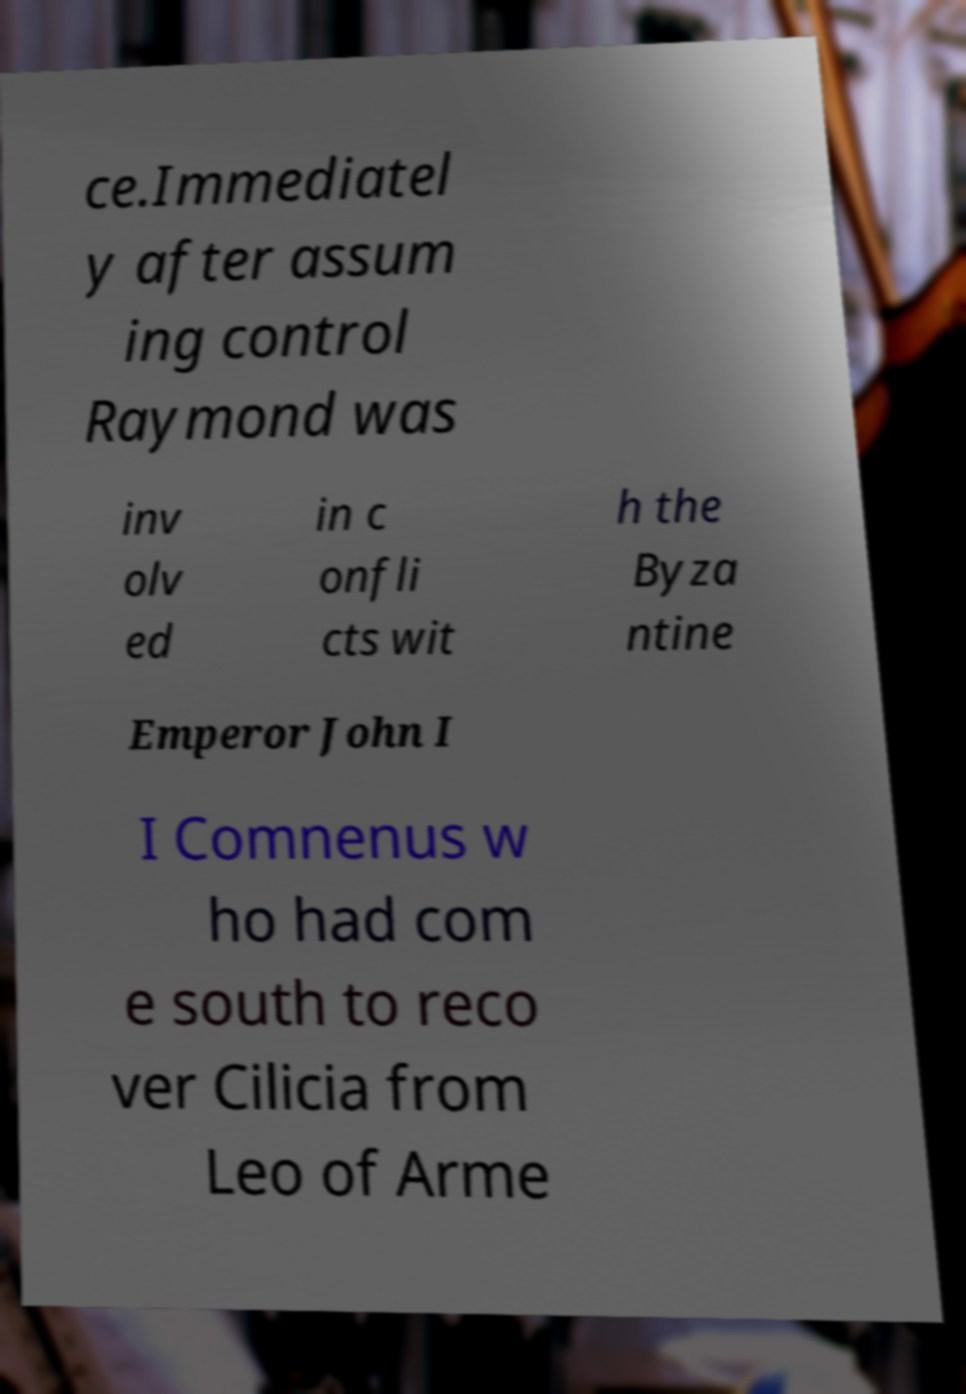Please read and relay the text visible in this image. What does it say? ce.Immediatel y after assum ing control Raymond was inv olv ed in c onfli cts wit h the Byza ntine Emperor John I I Comnenus w ho had com e south to reco ver Cilicia from Leo of Arme 